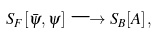<formula> <loc_0><loc_0><loc_500><loc_500>S _ { F } [ \bar { \psi } , \psi ] \longrightarrow S _ { B } [ A ] \, ,</formula> 